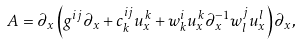Convert formula to latex. <formula><loc_0><loc_0><loc_500><loc_500>A = \partial _ { x } \left ( g ^ { i j } \partial _ { x } + c ^ { i j } _ { k } u ^ { k } _ { x } + w ^ { i } _ { k } u ^ { k } _ { x } \partial _ { x } ^ { - 1 } w ^ { j } _ { l } u ^ { l } _ { x } \right ) \partial _ { x } ,</formula> 